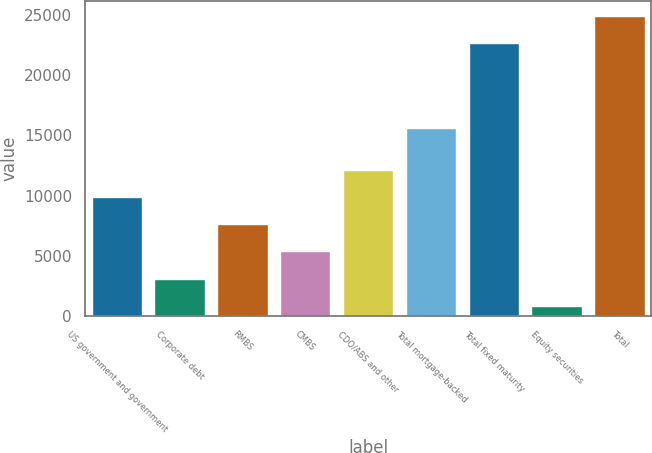Convert chart to OTSL. <chart><loc_0><loc_0><loc_500><loc_500><bar_chart><fcel>US government and government<fcel>Corporate debt<fcel>RMBS<fcel>CMBS<fcel>CDO/ABS and other<fcel>Total mortgage-backed<fcel>Total fixed maturity<fcel>Equity securities<fcel>Total<nl><fcel>9883.2<fcel>3096.3<fcel>7620.9<fcel>5358.6<fcel>12145.5<fcel>15601<fcel>22623<fcel>834<fcel>24885.3<nl></chart> 